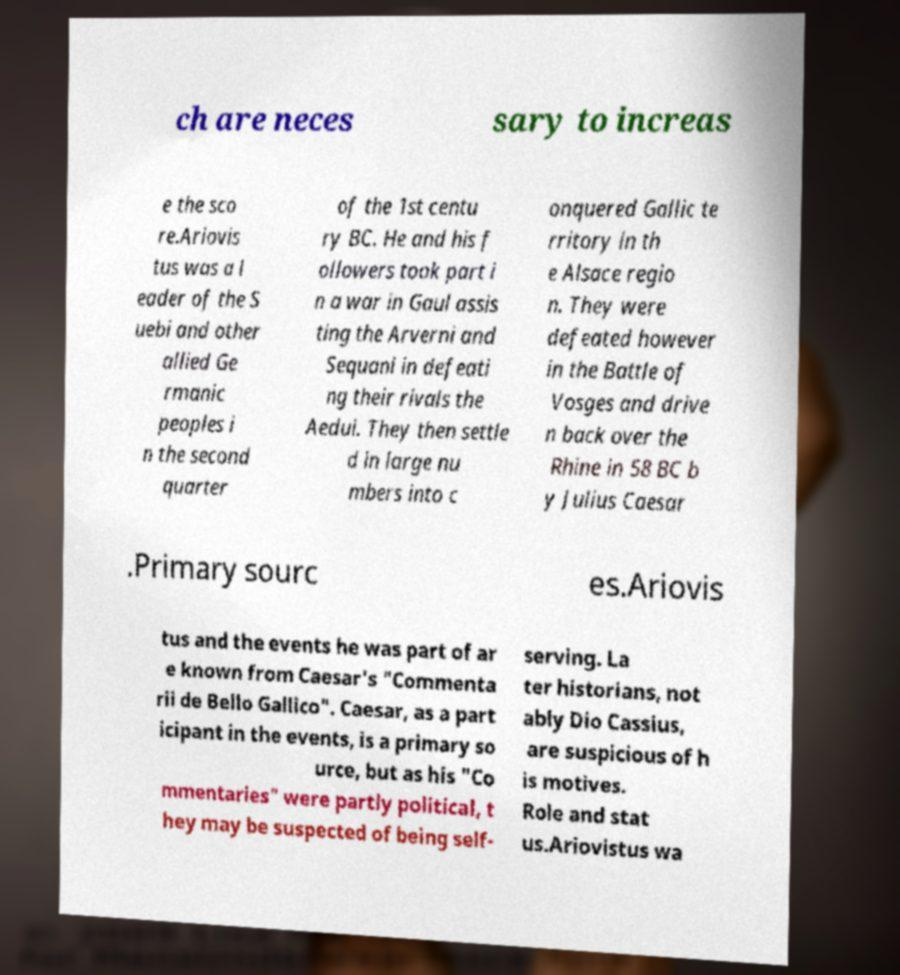Please identify and transcribe the text found in this image. ch are neces sary to increas e the sco re.Ariovis tus was a l eader of the S uebi and other allied Ge rmanic peoples i n the second quarter of the 1st centu ry BC. He and his f ollowers took part i n a war in Gaul assis ting the Arverni and Sequani in defeati ng their rivals the Aedui. They then settle d in large nu mbers into c onquered Gallic te rritory in th e Alsace regio n. They were defeated however in the Battle of Vosges and drive n back over the Rhine in 58 BC b y Julius Caesar .Primary sourc es.Ariovis tus and the events he was part of ar e known from Caesar's "Commenta rii de Bello Gallico". Caesar, as a part icipant in the events, is a primary so urce, but as his "Co mmentaries" were partly political, t hey may be suspected of being self- serving. La ter historians, not ably Dio Cassius, are suspicious of h is motives. Role and stat us.Ariovistus wa 